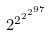<formula> <loc_0><loc_0><loc_500><loc_500>2 ^ { 2 ^ { 2 ^ { 2 ^ { 9 7 } } } }</formula> 